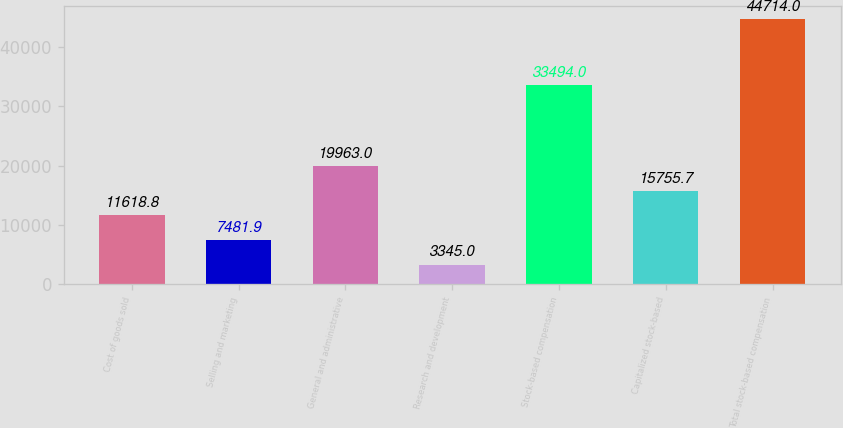<chart> <loc_0><loc_0><loc_500><loc_500><bar_chart><fcel>Cost of goods sold<fcel>Selling and marketing<fcel>General and administrative<fcel>Research and development<fcel>Stock-based compensation<fcel>Capitalized stock-based<fcel>Total stock-based compensation<nl><fcel>11618.8<fcel>7481.9<fcel>19963<fcel>3345<fcel>33494<fcel>15755.7<fcel>44714<nl></chart> 